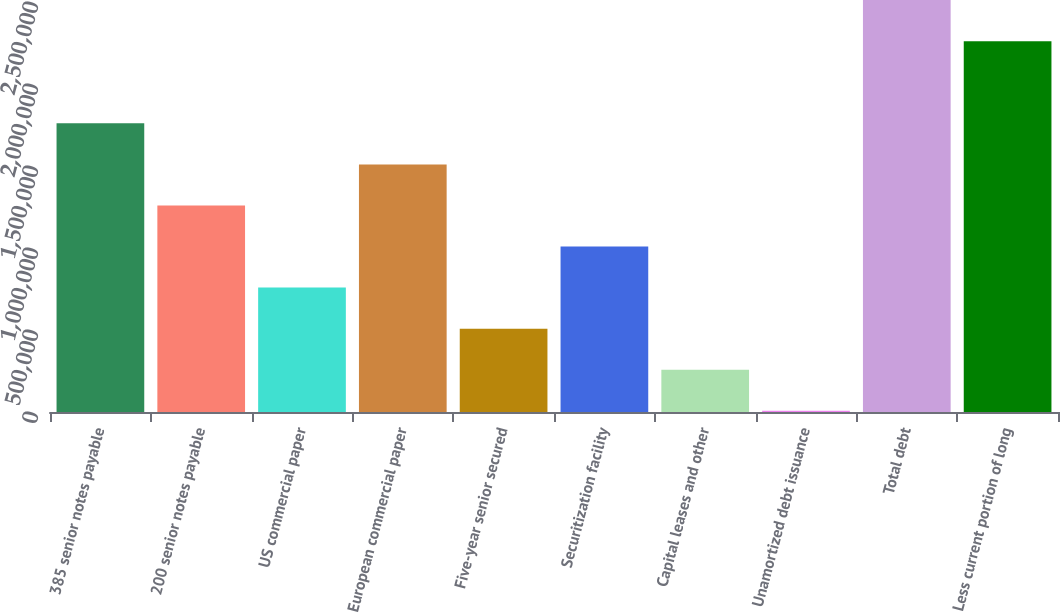<chart> <loc_0><loc_0><loc_500><loc_500><bar_chart><fcel>385 senior notes payable<fcel>200 senior notes payable<fcel>US commercial paper<fcel>European commercial paper<fcel>Five-year senior secured<fcel>Securitization facility<fcel>Capital leases and other<fcel>Unamortized debt issuance<fcel>Total debt<fcel>Less current portion of long<nl><fcel>1.76017e+06<fcel>1.2593e+06<fcel>758427<fcel>1.50974e+06<fcel>507991<fcel>1.00886e+06<fcel>257554<fcel>7117<fcel>2.51148e+06<fcel>2.26105e+06<nl></chart> 